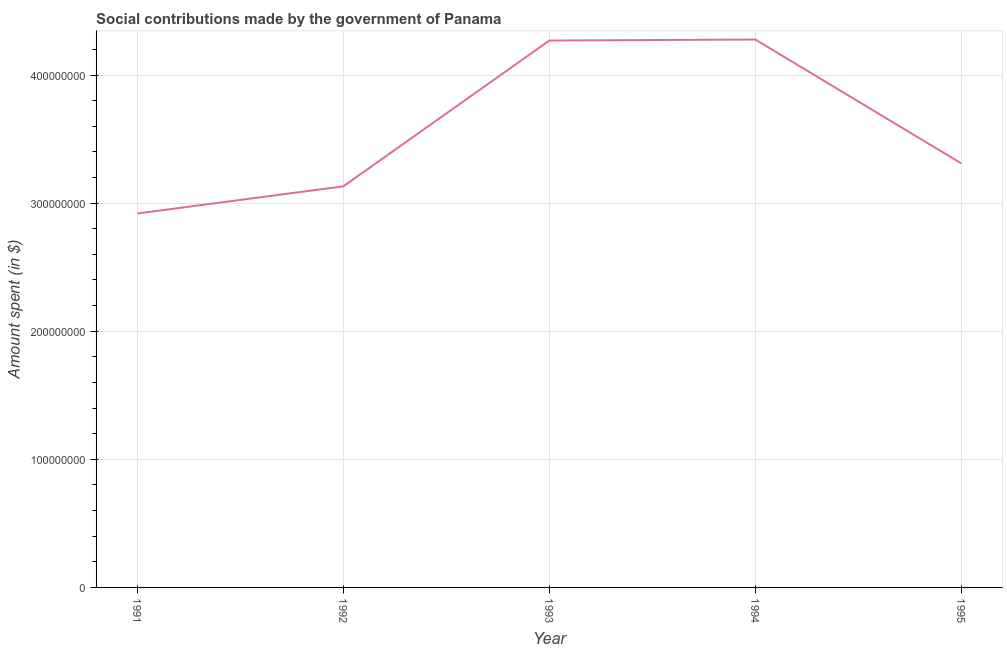What is the amount spent in making social contributions in 1994?
Offer a terse response. 4.28e+08. Across all years, what is the maximum amount spent in making social contributions?
Offer a terse response. 4.28e+08. Across all years, what is the minimum amount spent in making social contributions?
Offer a very short reply. 2.92e+08. In which year was the amount spent in making social contributions minimum?
Ensure brevity in your answer.  1991. What is the sum of the amount spent in making social contributions?
Your answer should be compact. 1.79e+09. What is the difference between the amount spent in making social contributions in 1991 and 1995?
Offer a very short reply. -3.91e+07. What is the average amount spent in making social contributions per year?
Provide a short and direct response. 3.58e+08. What is the median amount spent in making social contributions?
Give a very brief answer. 3.31e+08. What is the ratio of the amount spent in making social contributions in 1992 to that in 1995?
Make the answer very short. 0.95. What is the difference between the highest and the lowest amount spent in making social contributions?
Keep it short and to the point. 1.36e+08. In how many years, is the amount spent in making social contributions greater than the average amount spent in making social contributions taken over all years?
Your answer should be very brief. 2. Does the amount spent in making social contributions monotonically increase over the years?
Make the answer very short. No. What is the difference between two consecutive major ticks on the Y-axis?
Ensure brevity in your answer.  1.00e+08. Are the values on the major ticks of Y-axis written in scientific E-notation?
Offer a terse response. No. What is the title of the graph?
Keep it short and to the point. Social contributions made by the government of Panama. What is the label or title of the X-axis?
Your answer should be very brief. Year. What is the label or title of the Y-axis?
Provide a succinct answer. Amount spent (in $). What is the Amount spent (in $) of 1991?
Give a very brief answer. 2.92e+08. What is the Amount spent (in $) in 1992?
Offer a terse response. 3.13e+08. What is the Amount spent (in $) of 1993?
Ensure brevity in your answer.  4.27e+08. What is the Amount spent (in $) of 1994?
Your response must be concise. 4.28e+08. What is the Amount spent (in $) in 1995?
Your response must be concise. 3.31e+08. What is the difference between the Amount spent (in $) in 1991 and 1992?
Keep it short and to the point. -2.12e+07. What is the difference between the Amount spent (in $) in 1991 and 1993?
Give a very brief answer. -1.35e+08. What is the difference between the Amount spent (in $) in 1991 and 1994?
Provide a succinct answer. -1.36e+08. What is the difference between the Amount spent (in $) in 1991 and 1995?
Keep it short and to the point. -3.91e+07. What is the difference between the Amount spent (in $) in 1992 and 1993?
Provide a succinct answer. -1.14e+08. What is the difference between the Amount spent (in $) in 1992 and 1994?
Offer a terse response. -1.15e+08. What is the difference between the Amount spent (in $) in 1992 and 1995?
Your answer should be compact. -1.79e+07. What is the difference between the Amount spent (in $) in 1993 and 1994?
Keep it short and to the point. -8.00e+05. What is the difference between the Amount spent (in $) in 1993 and 1995?
Provide a short and direct response. 9.59e+07. What is the difference between the Amount spent (in $) in 1994 and 1995?
Give a very brief answer. 9.67e+07. What is the ratio of the Amount spent (in $) in 1991 to that in 1992?
Give a very brief answer. 0.93. What is the ratio of the Amount spent (in $) in 1991 to that in 1993?
Give a very brief answer. 0.68. What is the ratio of the Amount spent (in $) in 1991 to that in 1994?
Your answer should be very brief. 0.68. What is the ratio of the Amount spent (in $) in 1991 to that in 1995?
Your answer should be very brief. 0.88. What is the ratio of the Amount spent (in $) in 1992 to that in 1993?
Provide a short and direct response. 0.73. What is the ratio of the Amount spent (in $) in 1992 to that in 1994?
Make the answer very short. 0.73. What is the ratio of the Amount spent (in $) in 1992 to that in 1995?
Offer a terse response. 0.95. What is the ratio of the Amount spent (in $) in 1993 to that in 1995?
Ensure brevity in your answer.  1.29. What is the ratio of the Amount spent (in $) in 1994 to that in 1995?
Give a very brief answer. 1.29. 